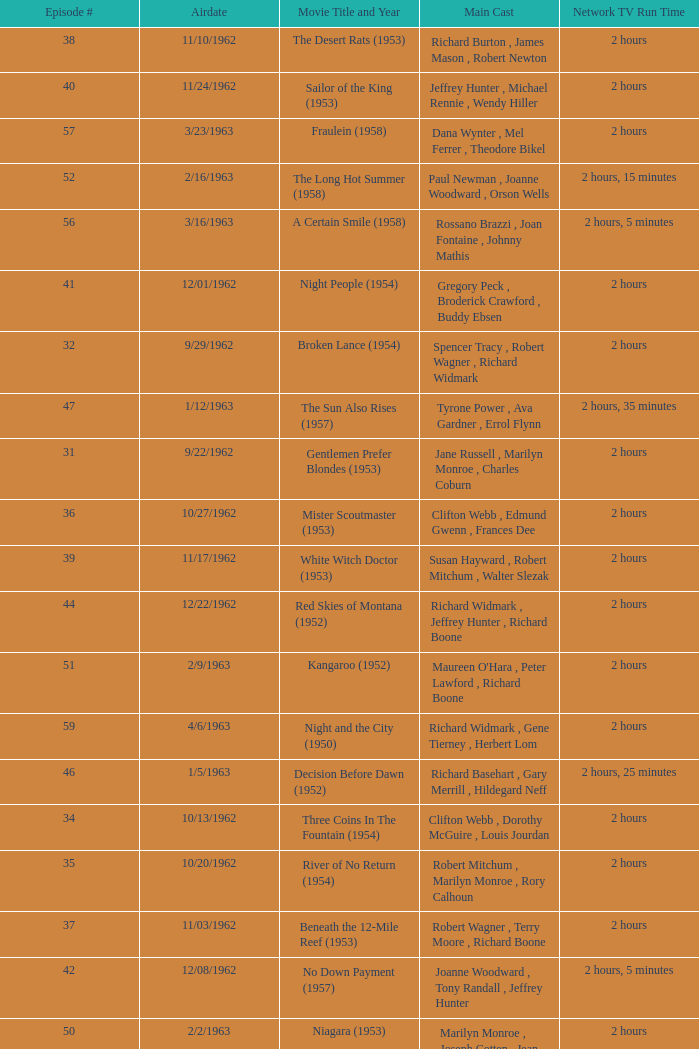What movie did dana wynter , mel ferrer , theodore bikel star in? Fraulein (1958). 